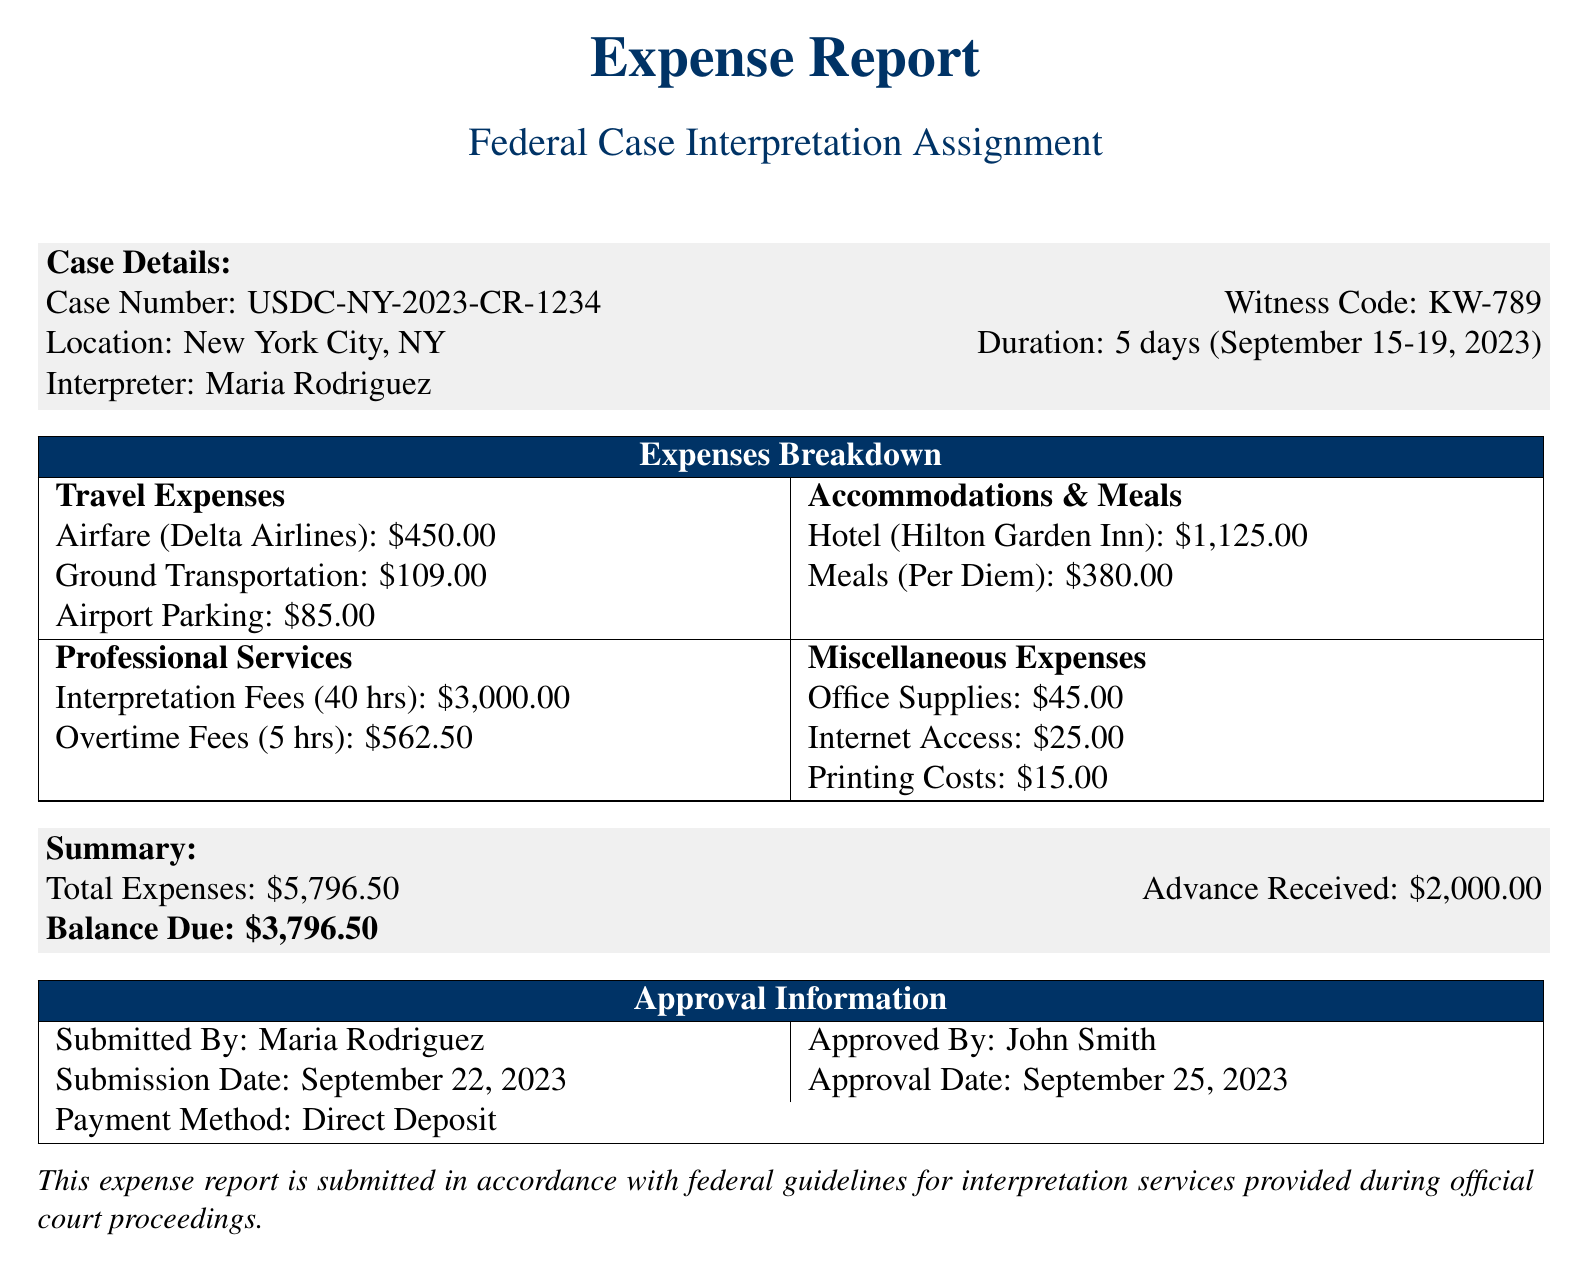what is the case number? The case number is found in the "Case Details" section of the document.
Answer: USDC-NY-2023-CR-1234 who is the assigned interpreter? The assigned interpreter's name is provided in the "Case Details" section.
Answer: Maria Rodriguez how much was spent on airfare? The airfare cost is specified in the "Travel Expenses" section.
Answer: 450.00 what was the total lodging cost? The total lodging cost can be calculated from the "Accommodations" section, which lists the room rate and nights stayed.
Answer: 1125.00 how many hours of interpretation were worked? The number of interpretation hours is located in the "Professional Services" section under interpretation fees.
Answer: 40 what is the total balance due? The total balance due is summarized at the end of the document.
Answer: 3796.50 when was the expense report submitted? The submission date is stated in the "Approval Information" section.
Answer: September 22, 2023 who approved the expense report? The person who approved the expense report is mentioned in the "Approval Information" section.
Answer: John Smith what is the payment method for the expenses? The payment method is specified in the "Approval Information" section of the document.
Answer: Direct Deposit 